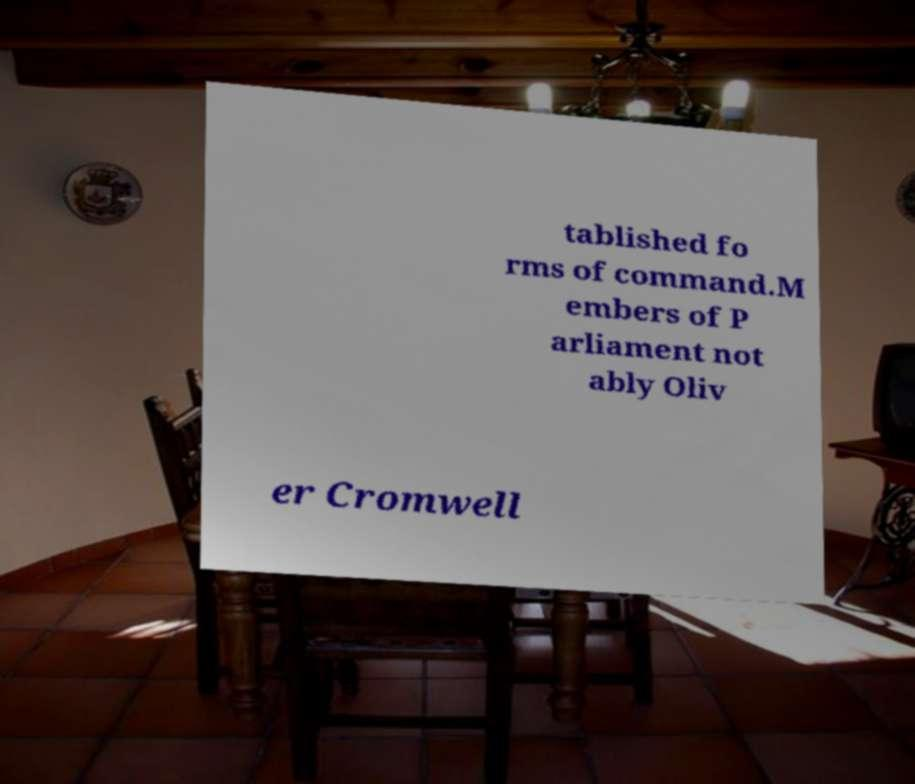Can you read and provide the text displayed in the image?This photo seems to have some interesting text. Can you extract and type it out for me? tablished fo rms of command.M embers of P arliament not ably Oliv er Cromwell 